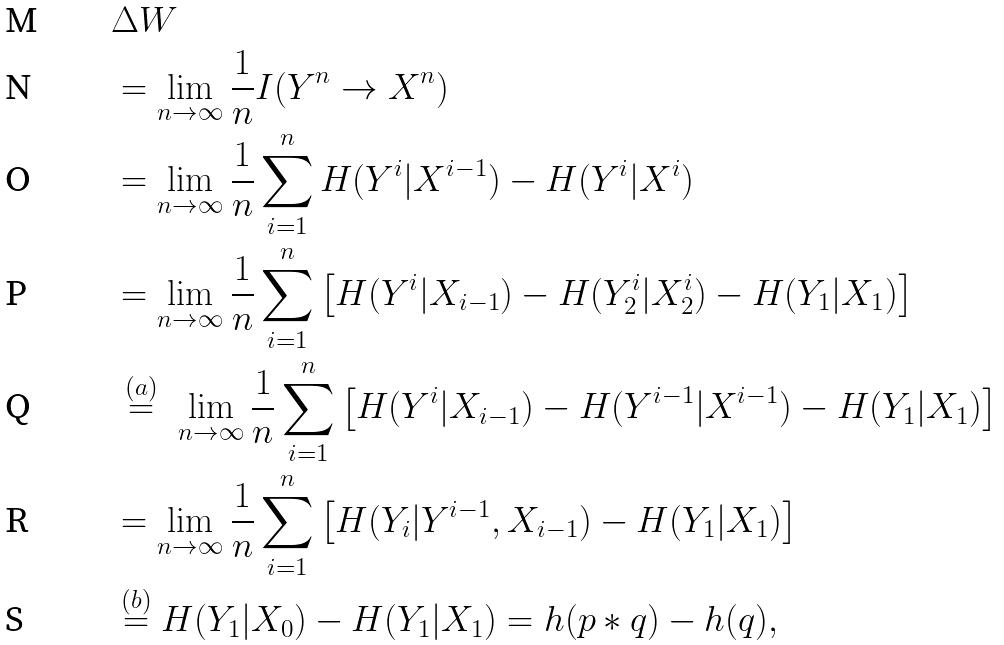<formula> <loc_0><loc_0><loc_500><loc_500>& { \Delta W } \\ & = \lim _ { n \to \infty } \frac { 1 } { n } I ( Y ^ { n } \to X ^ { n } ) \\ & = \lim _ { n \to \infty } \frac { 1 } { n } \sum _ { i = 1 } ^ { n } H ( Y ^ { i } | X ^ { i - 1 } ) - H ( Y ^ { i } | X ^ { i } ) \\ & = \lim _ { n \to \infty } \frac { 1 } { n } \sum _ { i = 1 } ^ { n } \left [ H ( Y ^ { i } | X _ { i - 1 } ) - H ( Y _ { 2 } ^ { i } | X _ { 2 } ^ { i } ) - H ( Y _ { 1 } | X _ { 1 } ) \right ] \\ & \stackrel { \, ( a ) \, } { = } \, \lim _ { n \to \infty } \frac { 1 } { n } \sum _ { i = 1 } ^ { n } \left [ H ( Y ^ { i } | X _ { i - 1 } ) - H ( Y ^ { i - 1 } | X ^ { i - 1 } ) - H ( Y _ { 1 } | X _ { 1 } ) \right ] \\ & = \lim _ { n \to \infty } \frac { 1 } { n } \sum _ { i = 1 } ^ { n } \left [ H ( Y _ { i } | Y ^ { i - 1 } , X _ { i - 1 } ) - H ( Y _ { 1 } | X _ { 1 } ) \right ] \\ & \stackrel { ( b ) } { = } H ( Y _ { 1 } | X _ { 0 } ) - H ( Y _ { 1 } | X _ { 1 } ) = h ( p * q ) - h ( q ) ,</formula> 